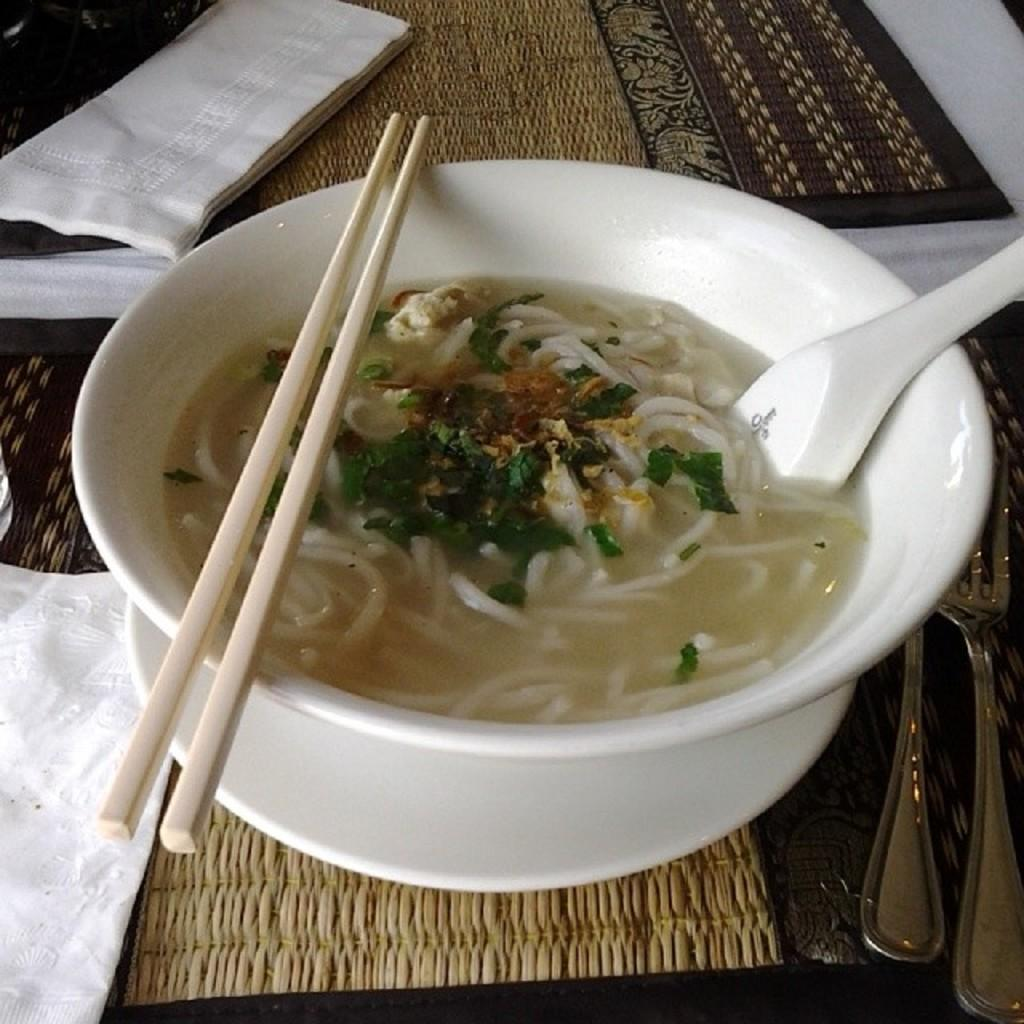What piece of furniture is present in the image? There is a table in the image. What is on top of the table? There is a bowl, a plate, a spoon, tissue, cloth, and a food item on the table. Can you describe the utensil on the table? There is a spoon on the table. What type of material is the cloth on the table made of? The cloth on the table is not specified, but it is present. How does the spy use the tray in the image? There is no tray present in the image, and therefore no spy or their actions can be observed. 